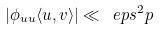<formula> <loc_0><loc_0><loc_500><loc_500>| \phi _ { u u } \langle u , v \rangle | \ll \ e p s ^ { 2 } p</formula> 